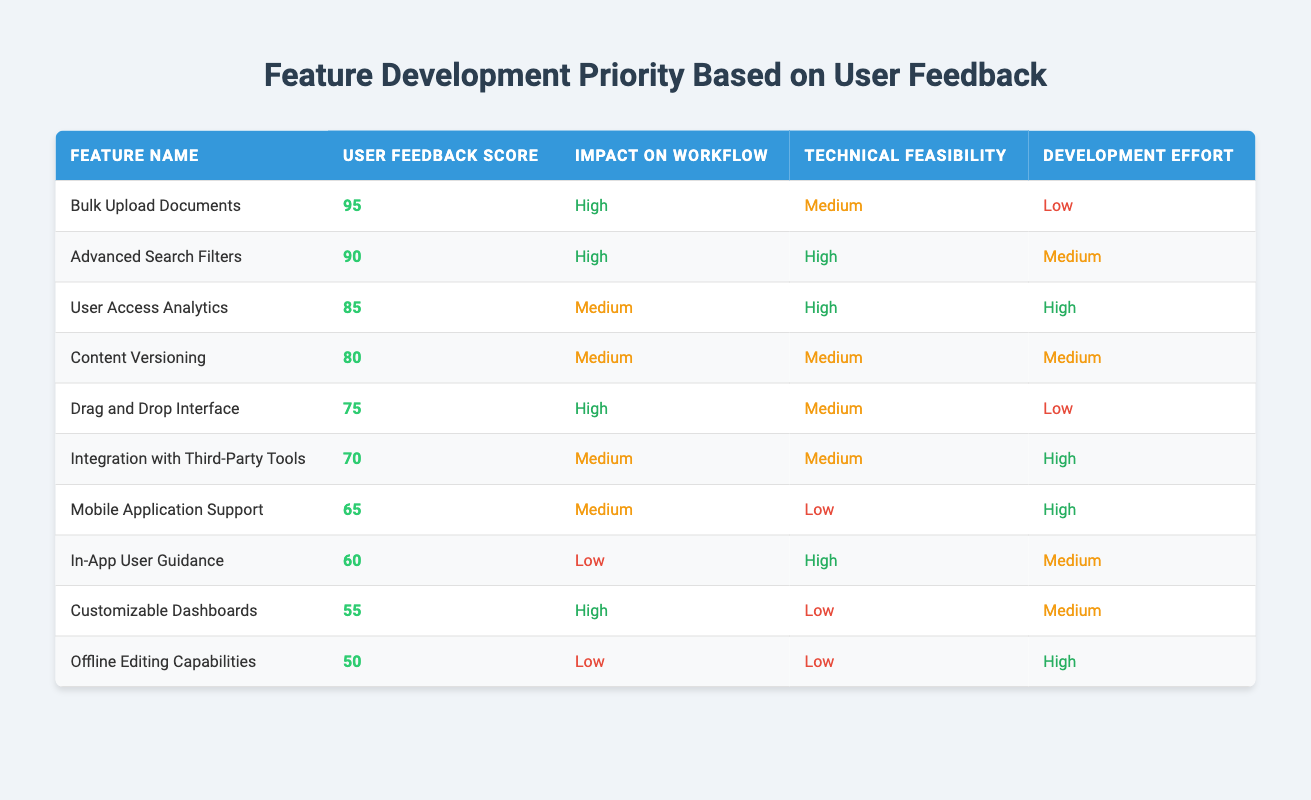What feature has the highest user feedback score? The table clearly indicates that "Bulk Upload Documents" has the highest user feedback score of 95.
Answer: Bulk Upload Documents How many features have a high impact on workflow? By scanning the table, I can see that "Bulk Upload Documents", "Advanced Search Filters", "Drag and Drop Interface", and "Customizable Dashboards" are labeled with a high impact on workflow. Counting these yields a total of 4 features.
Answer: 4 What is the development effort required for "User Access Analytics"? Looking at the row for "User Access Analytics", it states that the development effort is high.
Answer: High Which feature has the lowest user feedback score? "Offline Editing Capabilities" has the lowest user feedback score, which is indicated as 50 in the table.
Answer: Offline Editing Capabilities Is "Mobile Application Support" technically feasible? Upon examining the table, it shows that "Mobile Application Support" has a technical feasibility labeled as low. Therefore, it is not technically feasible.
Answer: No What is the average user feedback score of all the features with a high impact on workflow? The features with a high impact on workflow are "Bulk Upload Documents" (95), "Advanced Search Filters" (90), "Drag and Drop Interface" (75), and "Customizable Dashboards" (55). Summing these scores gives 95 + 90 + 75 + 55 = 315. There are 4 features, so the average is 315/4 = 78.75.
Answer: 78.75 Which feature presents the least technical feasibility among high impact features? Among the high-impact features, "Bulk Upload Documents" and "Drag and Drop Interface" are medium, while "Advanced Search Filters" is high, and "Customizable Dashboards" is low. The least technical feasibility is for "Customizable Dashboards" with a low rating.
Answer: Customizable Dashboards What is the difference in user feedback score between "Drag and Drop Interface" and "Content Versioning"? "Drag and Drop Interface" has a feedback score of 75, and "Content Versioning" has a score of 80. The difference is 80 - 75 = 5.
Answer: 5 Are there any features that require low development effort and have a high user feedback score? The table lists "Bulk Upload Documents" with a low development effort and a high user feedback score of 95. Therefore, there is at least one feature meeting this criterion.
Answer: Yes 